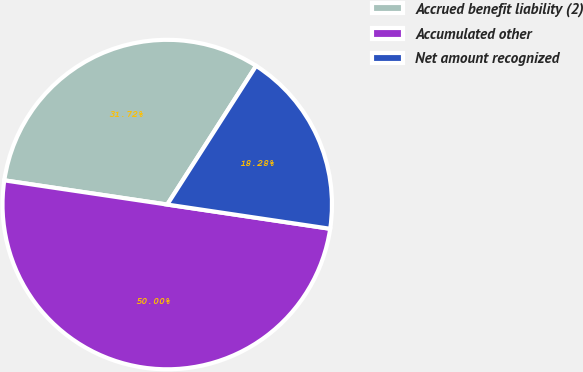<chart> <loc_0><loc_0><loc_500><loc_500><pie_chart><fcel>Accrued benefit liability (2)<fcel>Accumulated other<fcel>Net amount recognized<nl><fcel>31.72%<fcel>50.0%<fcel>18.28%<nl></chart> 